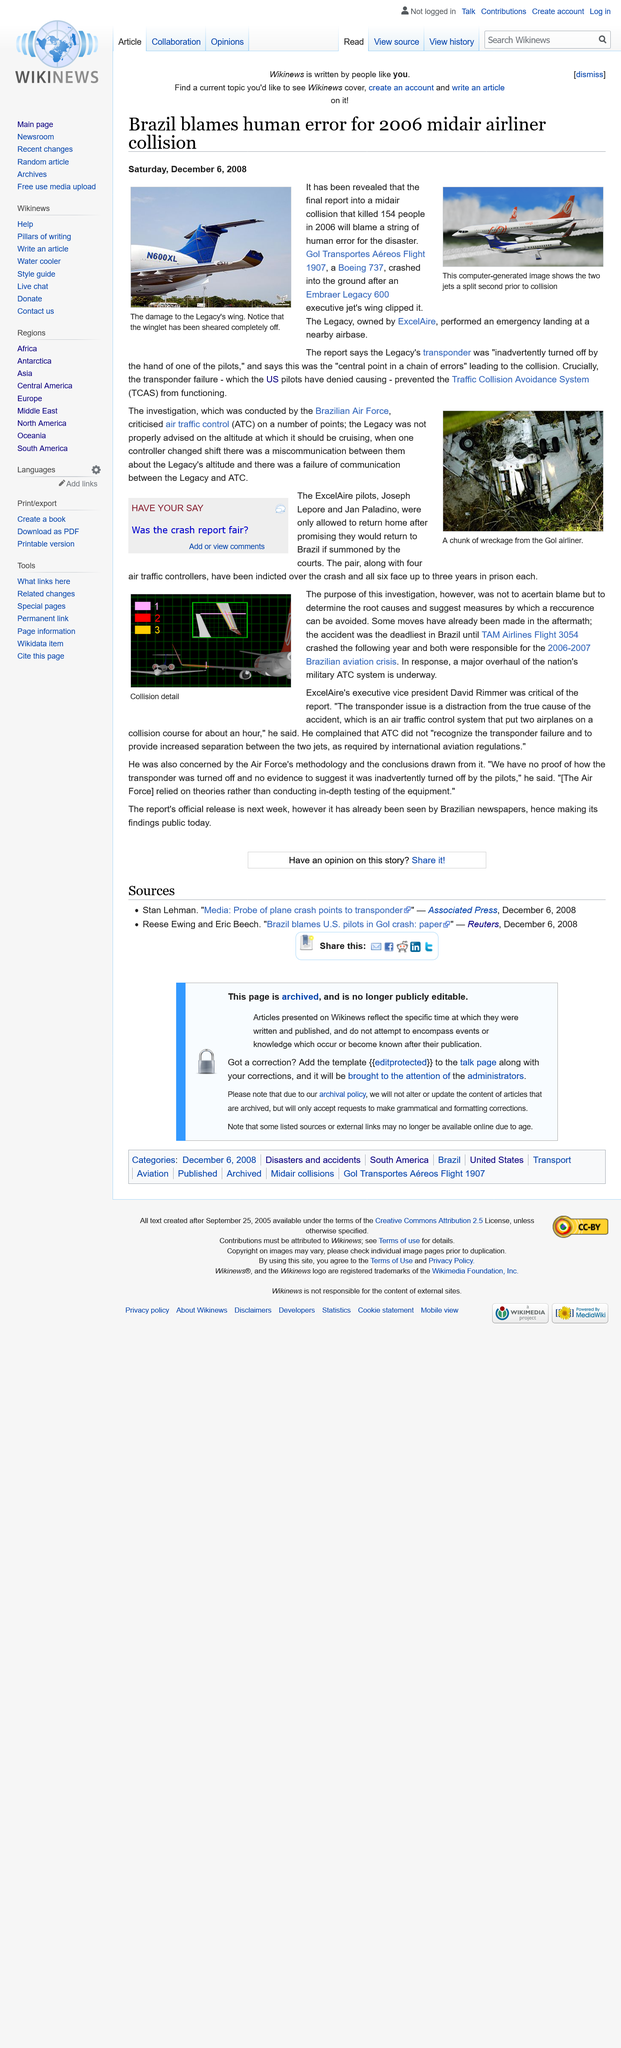Point out several critical features in this image. The 2006 mid-air airliner collision was caused by human error, specifically a transponder failure, according to Brazil's Civil Aviation Authority. The Embraer Legacy 600 executive jet's wing sustained significant damage during the 2006 midair collision with an airliner, with its winglet being completely sheared off. On July 19, 2006, two aircrafts were involved in a midair collision over the Amazon rainforest in Brazil. The crash involved Gol Transportes Aereos Flight 1907, a Boeing 737, and an Embraer Legacy 600 executive jet owned by ExcelAire. All 154 people on board the two aircrafts were killed. 